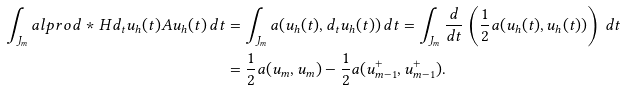<formula> <loc_0><loc_0><loc_500><loc_500>\int _ { J _ { m } } a l p r o d * { H } { d _ { t } u _ { h } ( t ) } { A u _ { h } ( t ) } \, d t & = \int _ { J _ { m } } a ( u _ { h } ( t ) , d _ { t } u _ { h } ( t ) ) \, d t = \int _ { J _ { m } } \frac { d } { d t } \left ( \frac { 1 } { 2 } a ( u _ { h } ( t ) , u _ { h } ( t ) ) \right ) \, d t \\ & = \frac { 1 } { 2 } a ( u _ { m } , u _ { m } ) - \frac { 1 } { 2 } a ( u _ { m - 1 } ^ { + } , u _ { m - 1 } ^ { + } ) .</formula> 